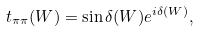<formula> <loc_0><loc_0><loc_500><loc_500>t _ { \pi \pi } ( W ) = \sin \delta ( W ) e ^ { i \delta ( W ) } ,</formula> 